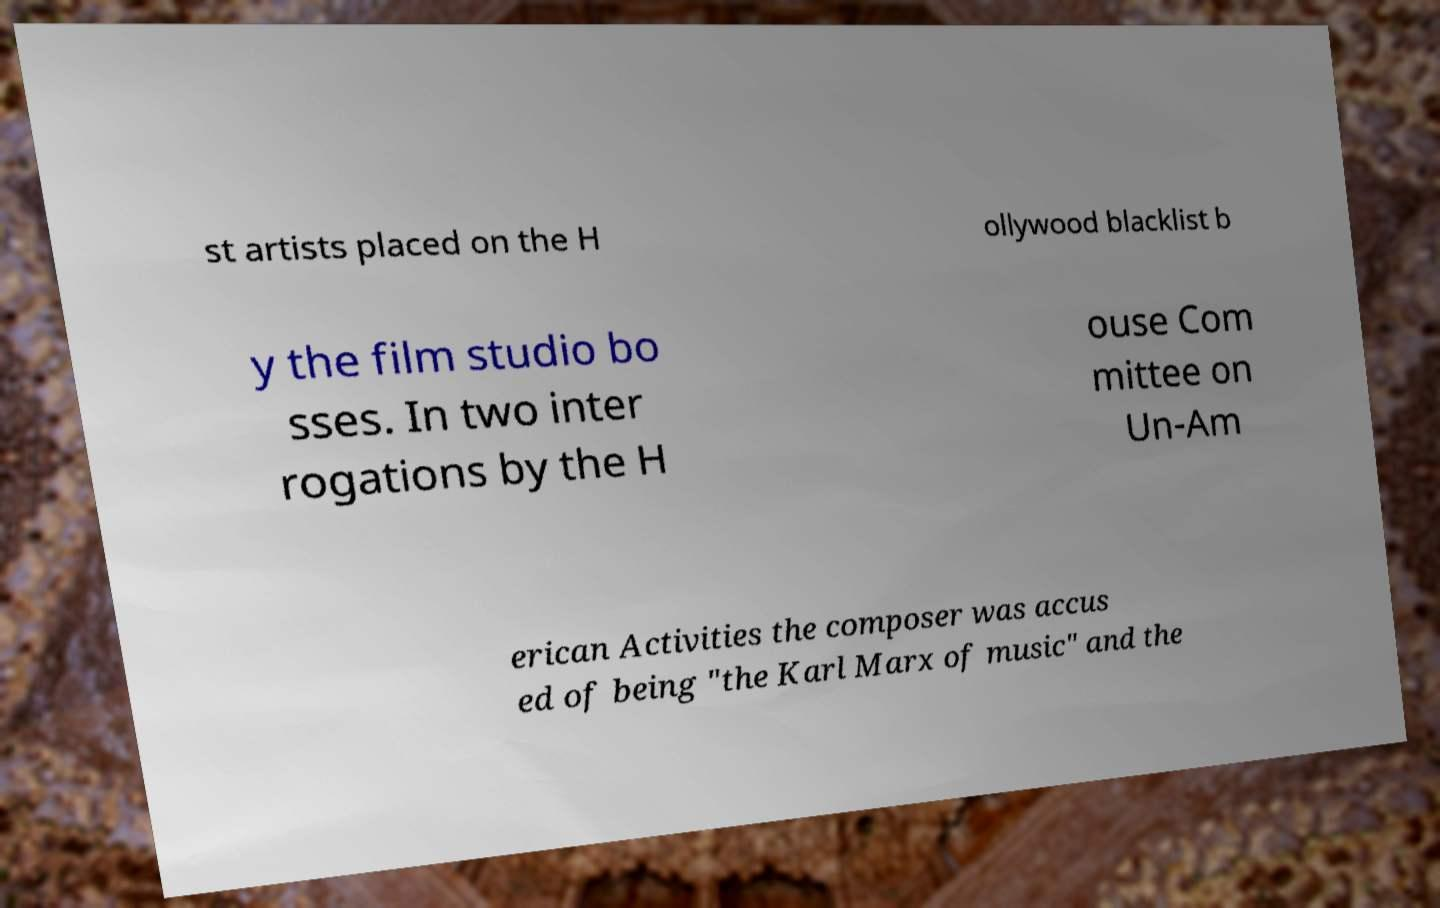What messages or text are displayed in this image? I need them in a readable, typed format. st artists placed on the H ollywood blacklist b y the film studio bo sses. In two inter rogations by the H ouse Com mittee on Un-Am erican Activities the composer was accus ed of being "the Karl Marx of music" and the 